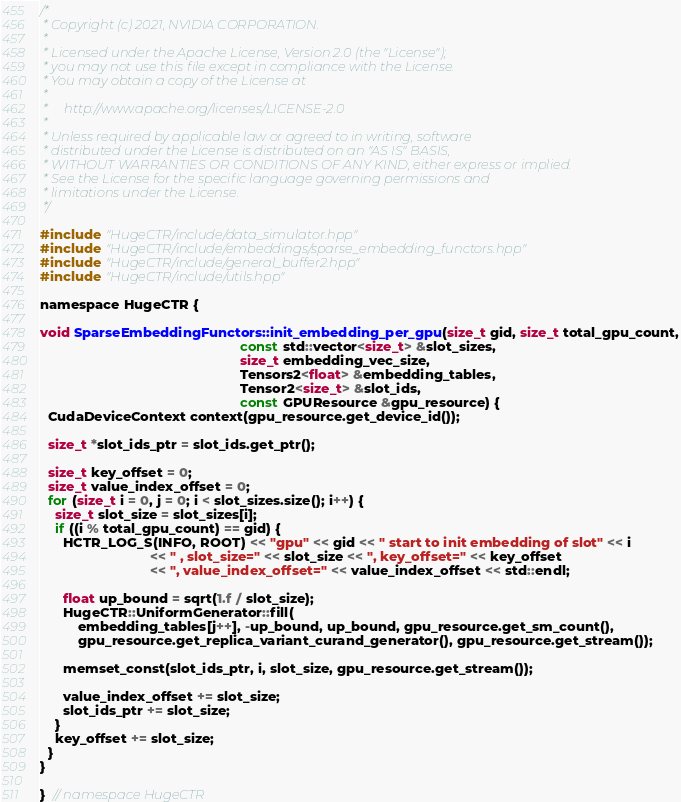<code> <loc_0><loc_0><loc_500><loc_500><_Cuda_>/*
 * Copyright (c) 2021, NVIDIA CORPORATION.
 *
 * Licensed under the Apache License, Version 2.0 (the "License");
 * you may not use this file except in compliance with the License.
 * You may obtain a copy of the License at
 *
 *     http://www.apache.org/licenses/LICENSE-2.0
 *
 * Unless required by applicable law or agreed to in writing, software
 * distributed under the License is distributed on an "AS IS" BASIS,
 * WITHOUT WARRANTIES OR CONDITIONS OF ANY KIND, either express or implied.
 * See the License for the specific language governing permissions and
 * limitations under the License.
 */

#include "HugeCTR/include/data_simulator.hpp"
#include "HugeCTR/include/embeddings/sparse_embedding_functors.hpp"
#include "HugeCTR/include/general_buffer2.hpp"
#include "HugeCTR/include/utils.hpp"

namespace HugeCTR {

void SparseEmbeddingFunctors::init_embedding_per_gpu(size_t gid, size_t total_gpu_count,
                                                     const std::vector<size_t> &slot_sizes,
                                                     size_t embedding_vec_size,
                                                     Tensors2<float> &embedding_tables,
                                                     Tensor2<size_t> &slot_ids,
                                                     const GPUResource &gpu_resource) {
  CudaDeviceContext context(gpu_resource.get_device_id());

  size_t *slot_ids_ptr = slot_ids.get_ptr();

  size_t key_offset = 0;
  size_t value_index_offset = 0;
  for (size_t i = 0, j = 0; i < slot_sizes.size(); i++) {
    size_t slot_size = slot_sizes[i];
    if ((i % total_gpu_count) == gid) {
      HCTR_LOG_S(INFO, ROOT) << "gpu" << gid << " start to init embedding of slot" << i
                             << " , slot_size=" << slot_size << ", key_offset=" << key_offset
                             << ", value_index_offset=" << value_index_offset << std::endl;

      float up_bound = sqrt(1.f / slot_size);
      HugeCTR::UniformGenerator::fill(
          embedding_tables[j++], -up_bound, up_bound, gpu_resource.get_sm_count(),
          gpu_resource.get_replica_variant_curand_generator(), gpu_resource.get_stream());

      memset_const(slot_ids_ptr, i, slot_size, gpu_resource.get_stream());

      value_index_offset += slot_size;
      slot_ids_ptr += slot_size;
    }
    key_offset += slot_size;
  }
}

}  // namespace HugeCTR
</code> 